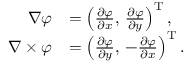<formula> <loc_0><loc_0><loc_500><loc_500>{ \begin{array} { r l } { \nabla \varphi } & { = \left ( { \frac { \partial \varphi } { \partial x } } , \, { \frac { \partial \varphi } { \partial y } } \right ) ^ { T } , } \\ { \nabla \times \varphi } & { = \left ( { \frac { \partial \varphi } { \partial y } } , \, - { \frac { \partial \varphi } { \partial x } } \right ) ^ { T } . } \end{array} }</formula> 